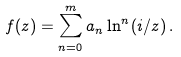<formula> <loc_0><loc_0><loc_500><loc_500>f ( z ) = \sum _ { n = 0 } ^ { m } a _ { n } \ln ^ { n } ( i / z ) \, .</formula> 